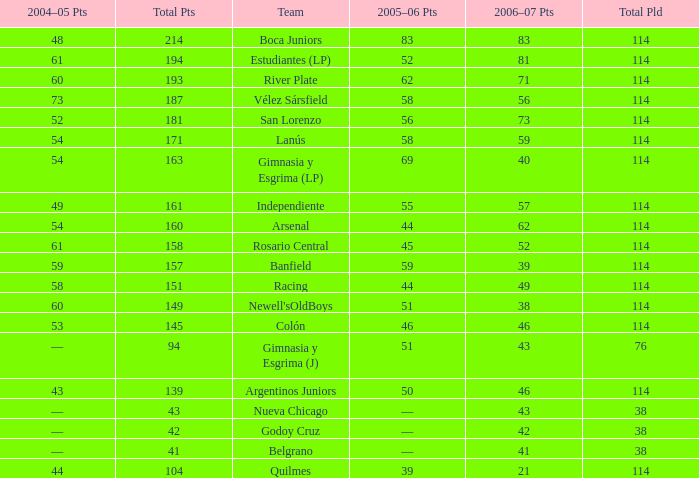What is the total number of points for a total pld less than 38? 0.0. 